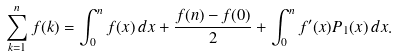<formula> <loc_0><loc_0><loc_500><loc_500>\sum _ { k = 1 } ^ { n } f ( k ) = \int _ { 0 } ^ { n } f ( x ) \, d x + { \frac { f ( n ) - f ( 0 ) } { 2 } } + \int _ { 0 } ^ { n } f ^ { \prime } ( x ) P _ { 1 } ( x ) \, d x .</formula> 